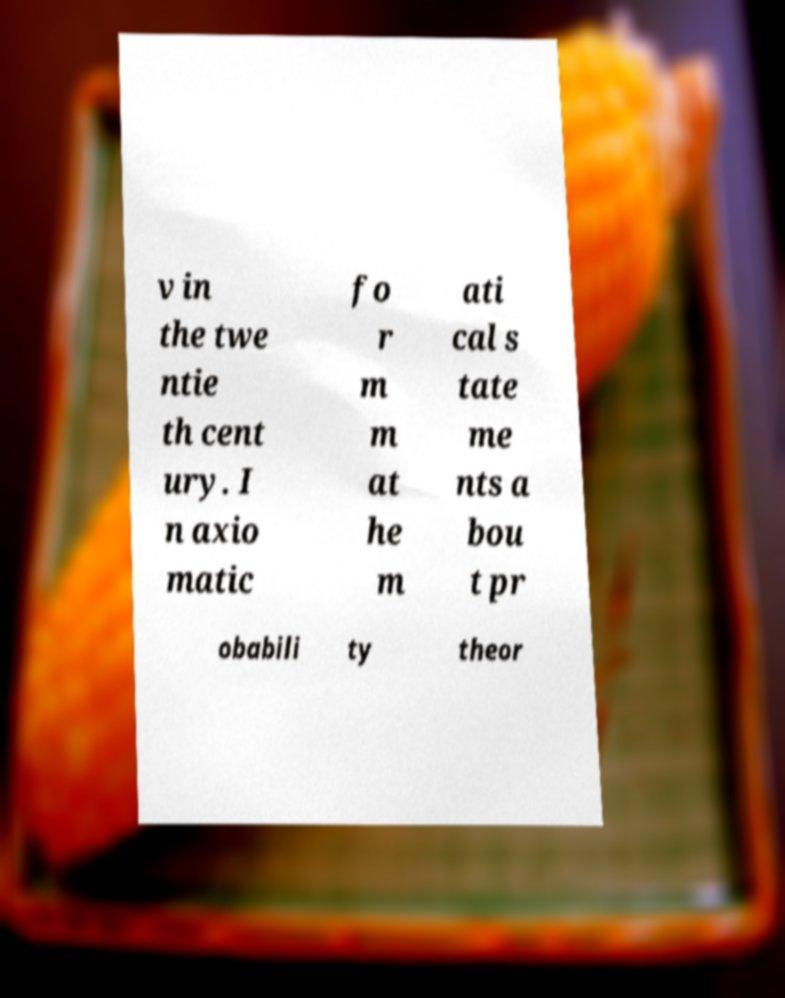Could you extract and type out the text from this image? v in the twe ntie th cent ury. I n axio matic fo r m m at he m ati cal s tate me nts a bou t pr obabili ty theor 